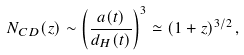<formula> <loc_0><loc_0><loc_500><loc_500>N _ { C D } ( z ) \sim \left ( { \frac { a ( t ) } { d _ { H } ( t ) } } \right ) ^ { 3 } \simeq ( 1 + z ) ^ { 3 / 2 } \, ,</formula> 